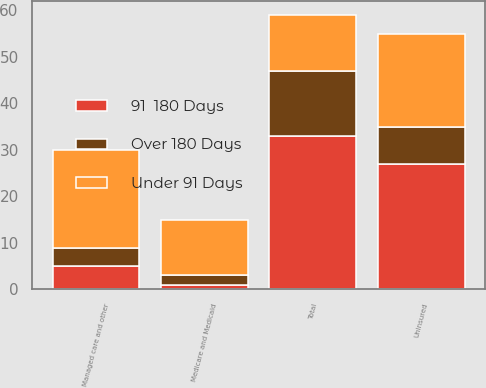Convert chart. <chart><loc_0><loc_0><loc_500><loc_500><stacked_bar_chart><ecel><fcel>Medicare and Medicaid<fcel>Managed care and other<fcel>Uninsured<fcel>Total<nl><fcel>Under 91 Days<fcel>12<fcel>21<fcel>20<fcel>12<nl><fcel>Over 180 Days<fcel>2<fcel>4<fcel>8<fcel>14<nl><fcel>91  180 Days<fcel>1<fcel>5<fcel>27<fcel>33<nl></chart> 